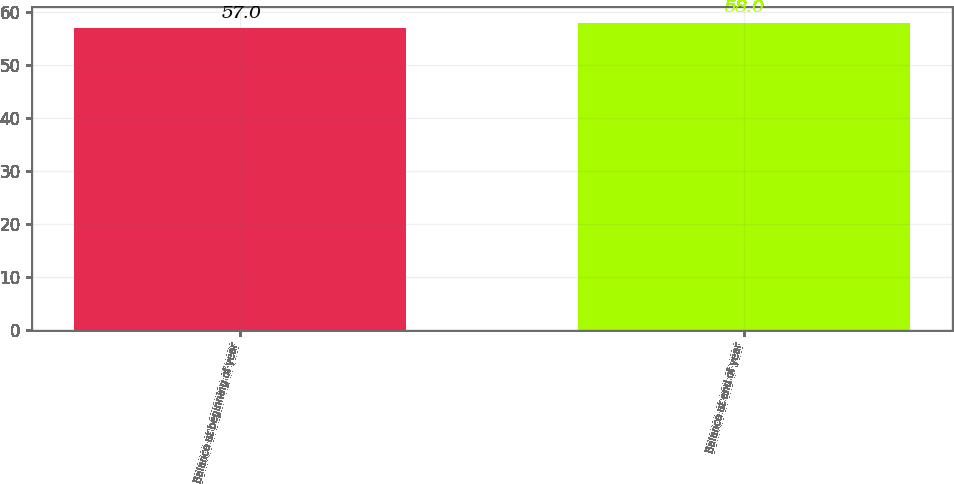Convert chart to OTSL. <chart><loc_0><loc_0><loc_500><loc_500><bar_chart><fcel>Balance at beginning of year<fcel>Balance at end of year<nl><fcel>57<fcel>58<nl></chart> 